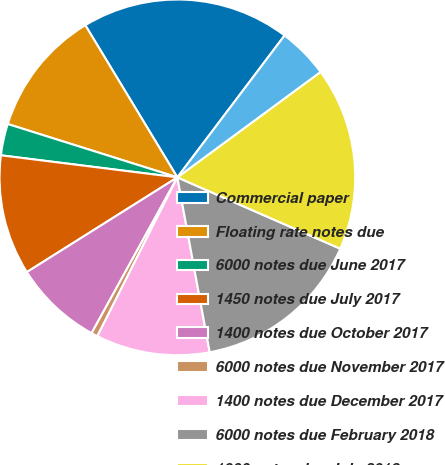<chart> <loc_0><loc_0><loc_500><loc_500><pie_chart><fcel>Commercial paper<fcel>Floating rate notes due<fcel>6000 notes due June 2017<fcel>1450 notes due July 2017<fcel>1400 notes due October 2017<fcel>6000 notes due November 2017<fcel>1400 notes due December 2017<fcel>6000 notes due February 2018<fcel>1900 notes due July 2018<fcel>1625 notes due March 2019<nl><fcel>18.96%<fcel>11.49%<fcel>2.87%<fcel>10.92%<fcel>8.05%<fcel>0.58%<fcel>10.34%<fcel>15.52%<fcel>16.67%<fcel>4.6%<nl></chart> 